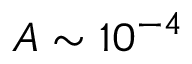Convert formula to latex. <formula><loc_0><loc_0><loc_500><loc_500>A \sim 1 0 ^ { - 4 }</formula> 